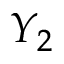<formula> <loc_0><loc_0><loc_500><loc_500>Y _ { 2 }</formula> 